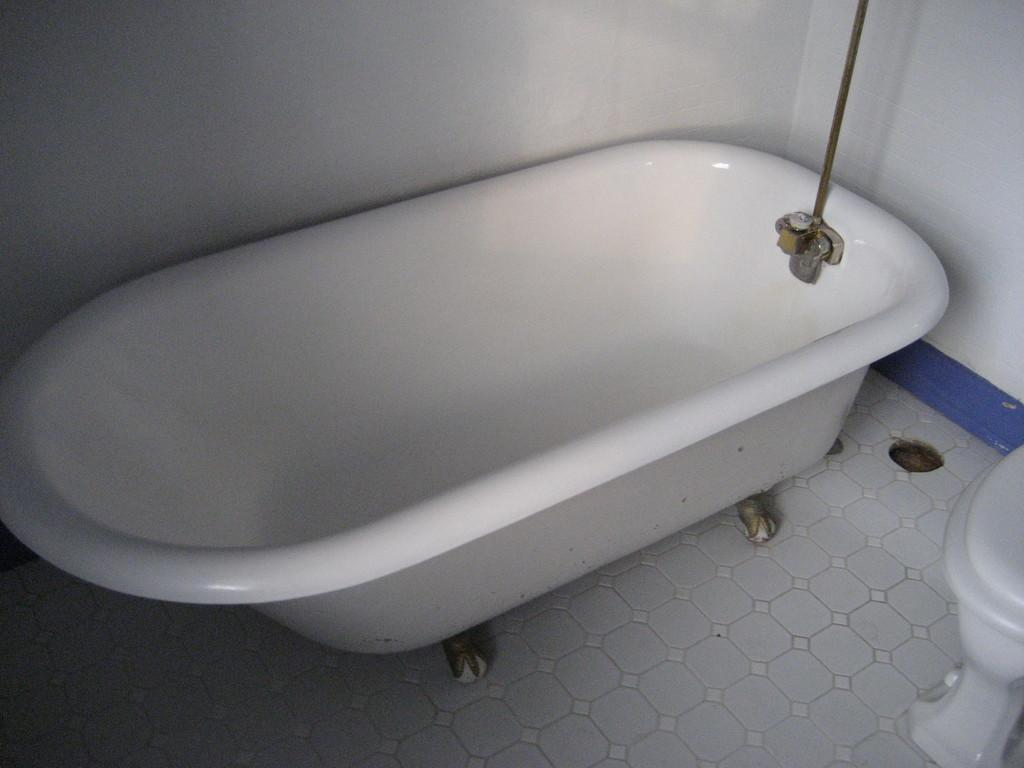What is the main object in the image? There is a bathtub in the image. Where is the bathtub located? The bathtub is on the floor. What other bathroom fixture is visible in the image? There is a toilet beside the bathtub. What color is the wall in the background of the image? The wall in the background of the image is white. What is the family's reaction to the fifth bathtub in the image? There is no mention of a family or a fifth bathtub in the image; it only shows one bathtub and a toilet. 